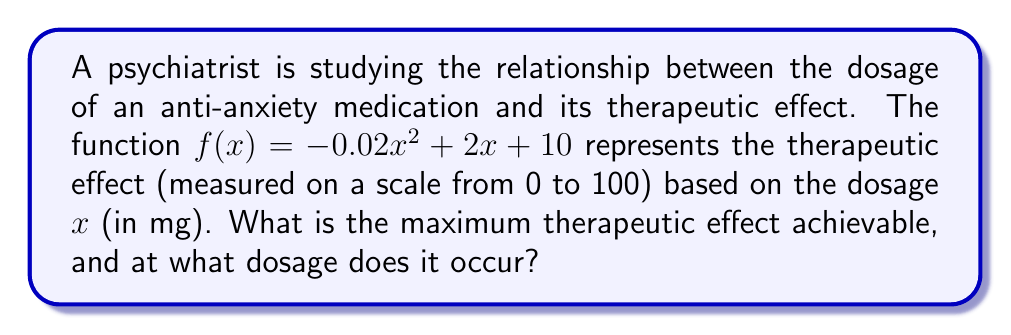Help me with this question. To find the maximum therapeutic effect and the corresponding dosage, we need to follow these steps:

1) The function $f(x) = -0.02x^2 + 2x + 10$ is a quadratic function, which forms a parabola. The maximum point of this parabola will give us the maximum therapeutic effect.

2) For a quadratic function in the form $f(x) = ax^2 + bx + c$, the x-coordinate of the vertex (which gives the dosage for maximum effect) is given by $x = -\frac{b}{2a}$.

3) In this case, $a = -0.02$, $b = 2$, and $c = 10$. Let's substitute these values:

   $x = -\frac{2}{2(-0.02)} = -\frac{2}{-0.04} = 50$

4) So, the maximum therapeutic effect occurs at a dosage of 50 mg.

5) To find the maximum therapeutic effect, we need to calculate $f(50)$:

   $f(50) = -0.02(50)^2 + 2(50) + 10$
   $      = -0.02(2500) + 100 + 10$
   $      = -50 + 100 + 10$
   $      = 60$

Therefore, the maximum therapeutic effect is 60 on the scale of 0 to 100, occurring at a dosage of 50 mg.
Answer: Maximum effect: 60; Dosage: 50 mg 